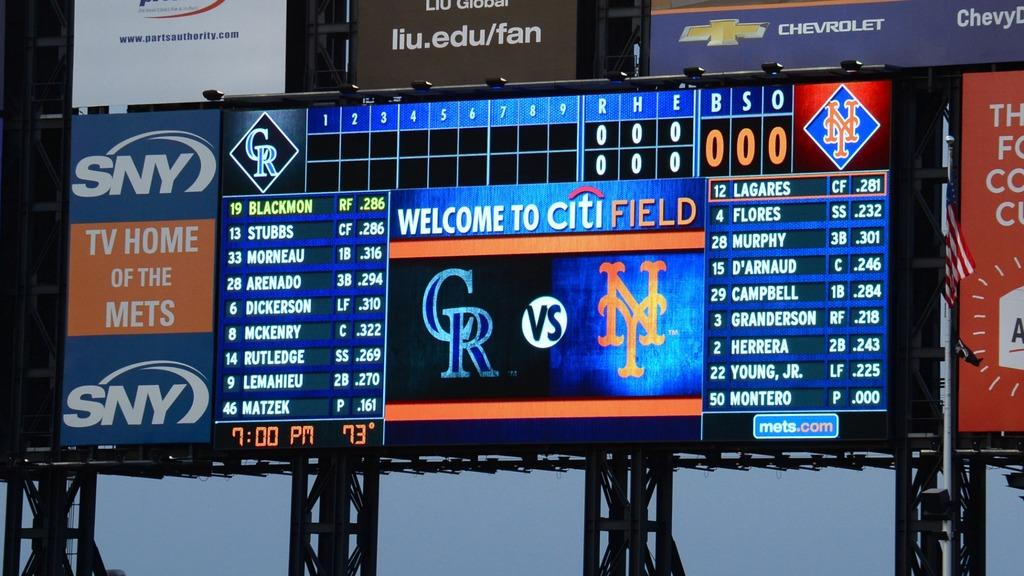<image>
Render a clear and concise summary of the photo. the scoreboard at the mets stadium citi field 